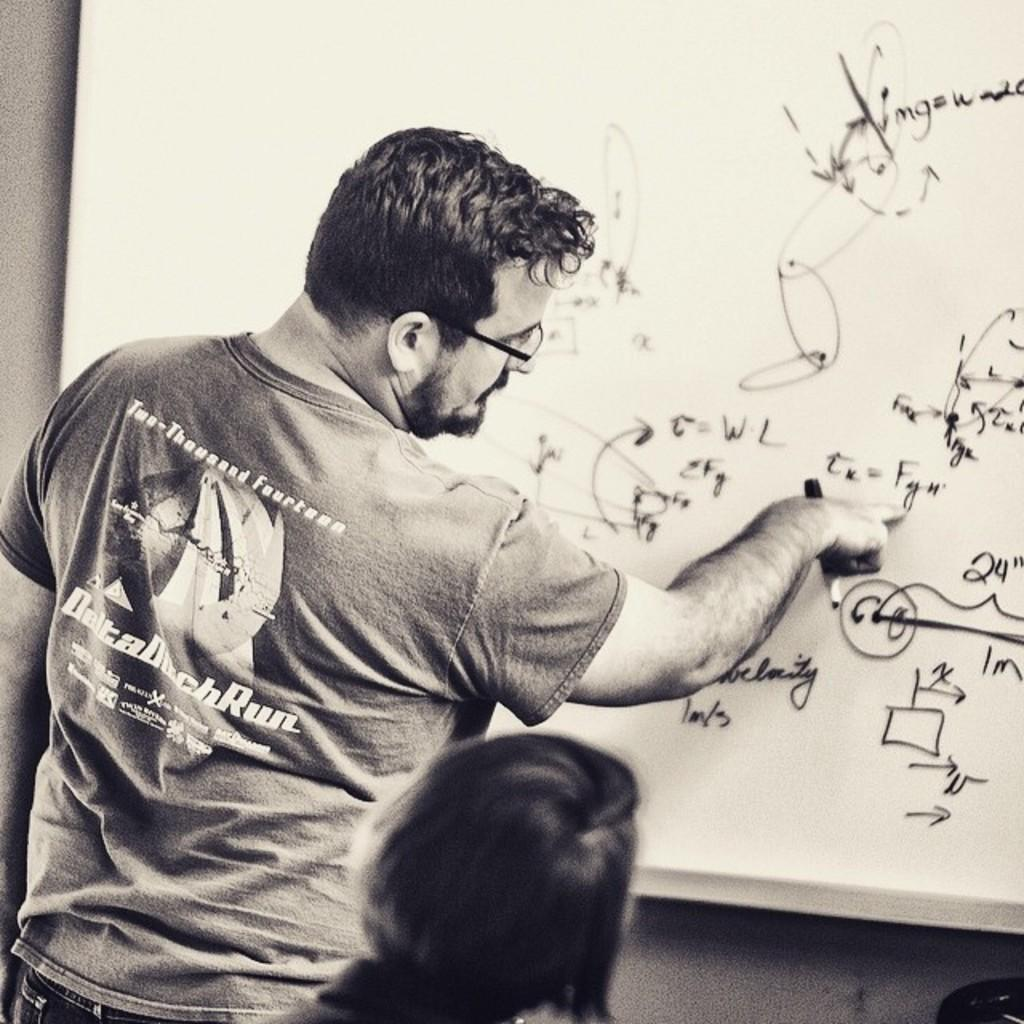<image>
Share a concise interpretation of the image provided. A man wearing a 2014 Delta Duck Run shirt writing on a whiteboard. 